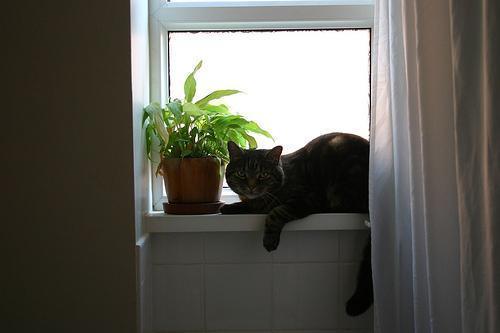How many cats are there?
Give a very brief answer. 1. 